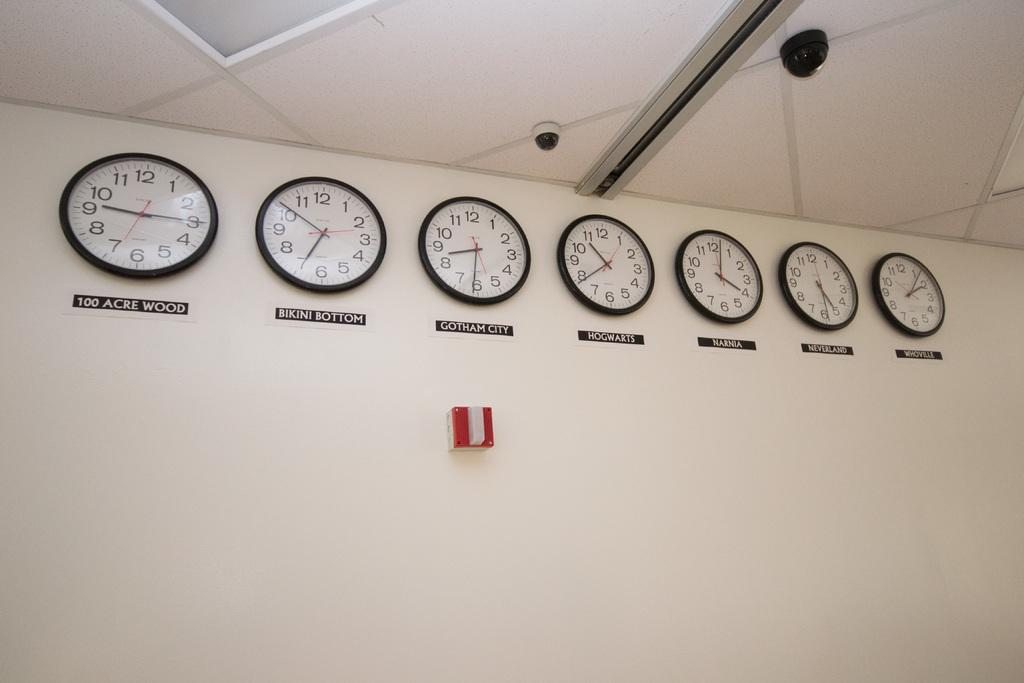<image>
Present a compact description of the photo's key features. Clocks from different fictional places, including Bikini Bottom and Hogwarts. 